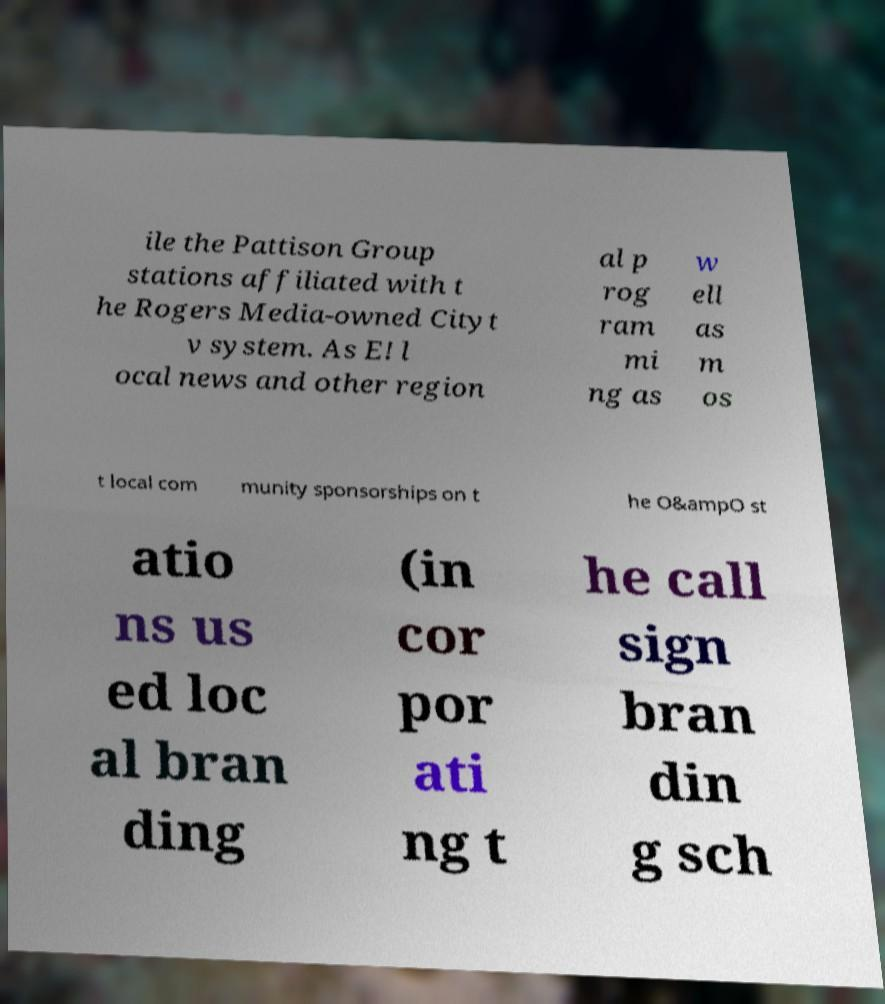There's text embedded in this image that I need extracted. Can you transcribe it verbatim? ile the Pattison Group stations affiliated with t he Rogers Media-owned Cityt v system. As E! l ocal news and other region al p rog ram mi ng as w ell as m os t local com munity sponsorships on t he O&ampO st atio ns us ed loc al bran ding (in cor por ati ng t he call sign bran din g sch 